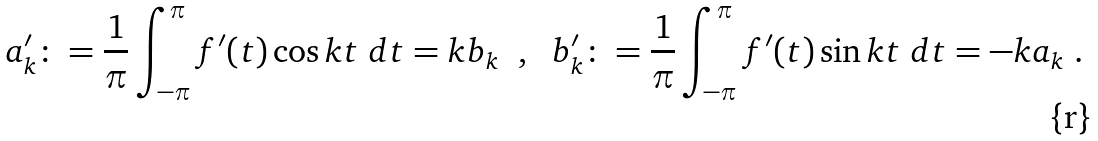<formula> <loc_0><loc_0><loc_500><loc_500>a ^ { \prime } _ { k } \colon = \frac { 1 } { \pi } \int _ { - \pi } ^ { \pi } f ^ { \prime } ( t ) \cos k t \ d t = k b _ { k } \ \ , \ \ b ^ { \prime } _ { k } \colon = \frac { 1 } { \pi } \int _ { - \pi } ^ { \pi } f ^ { \prime } ( t ) \sin k t \ d t = - k a _ { k } \ .</formula> 